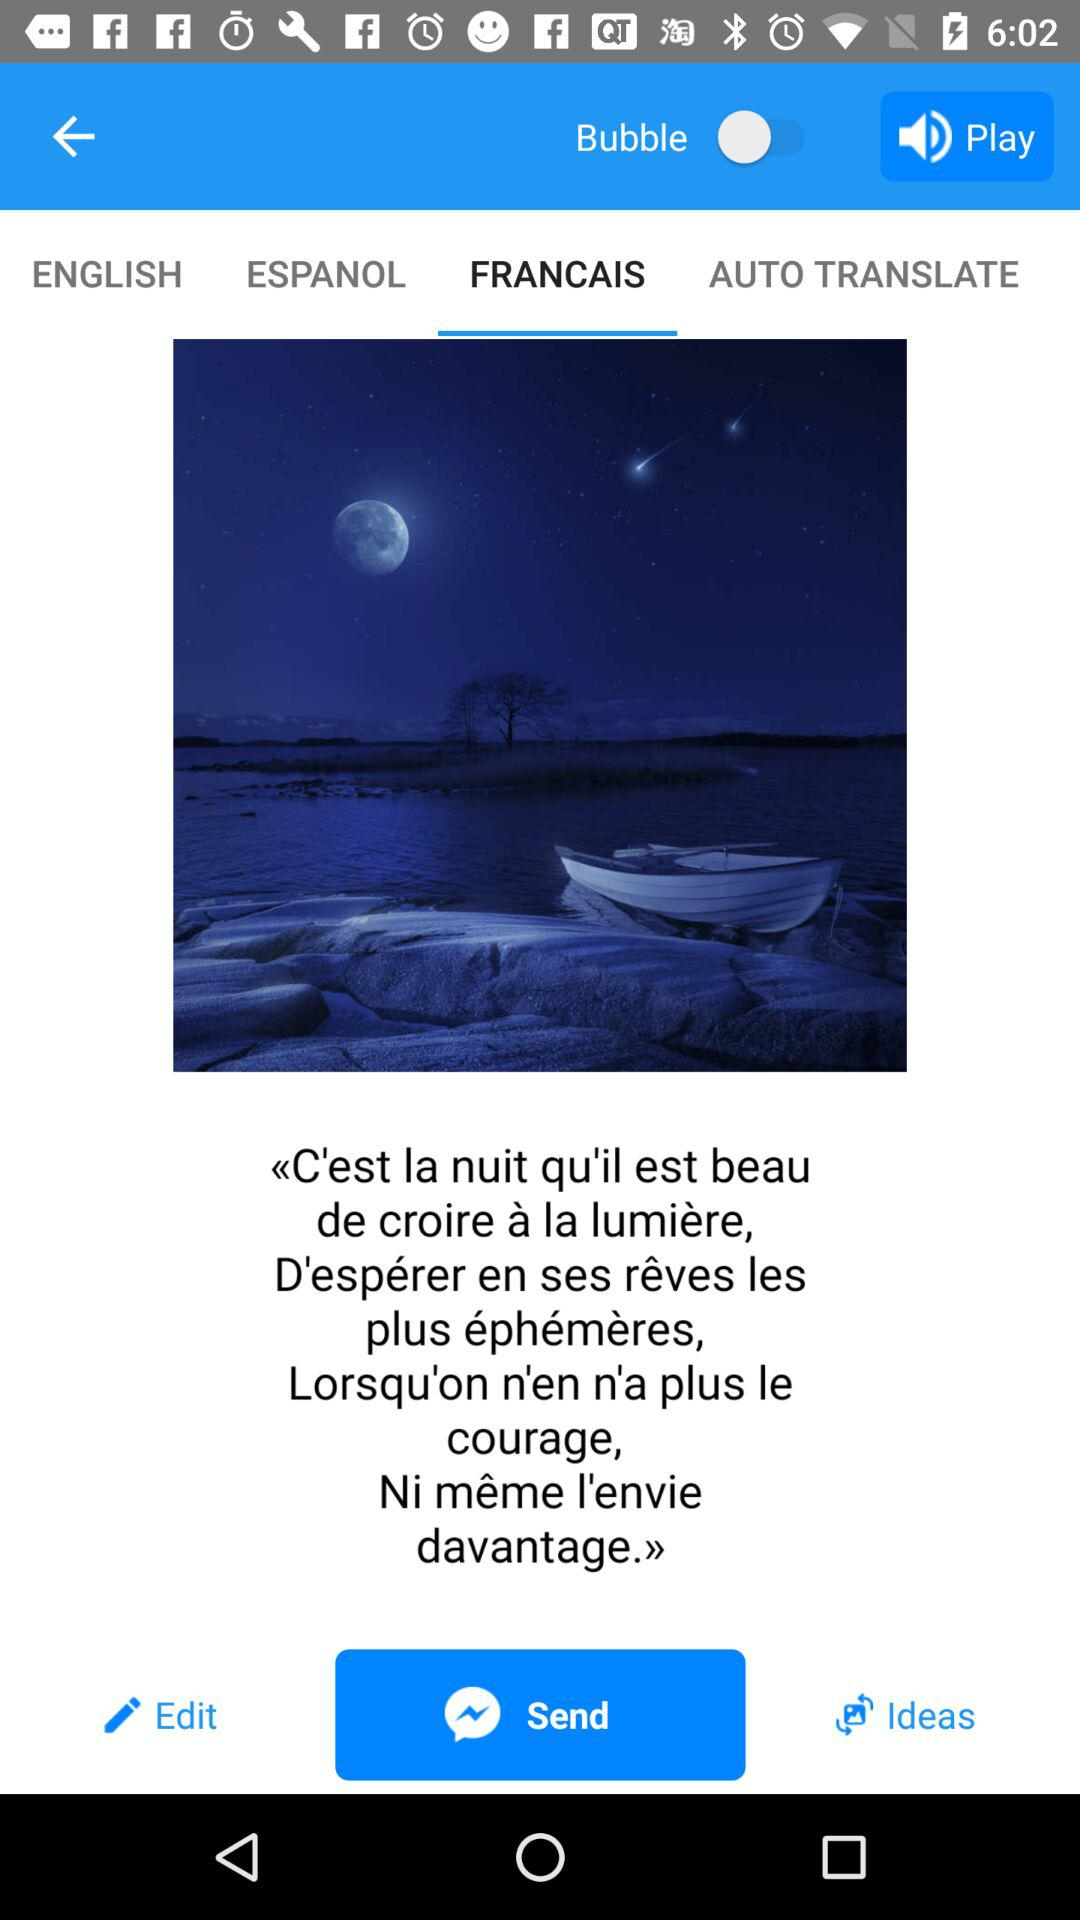What is the status of "Bubble" setting? The status is "on". 